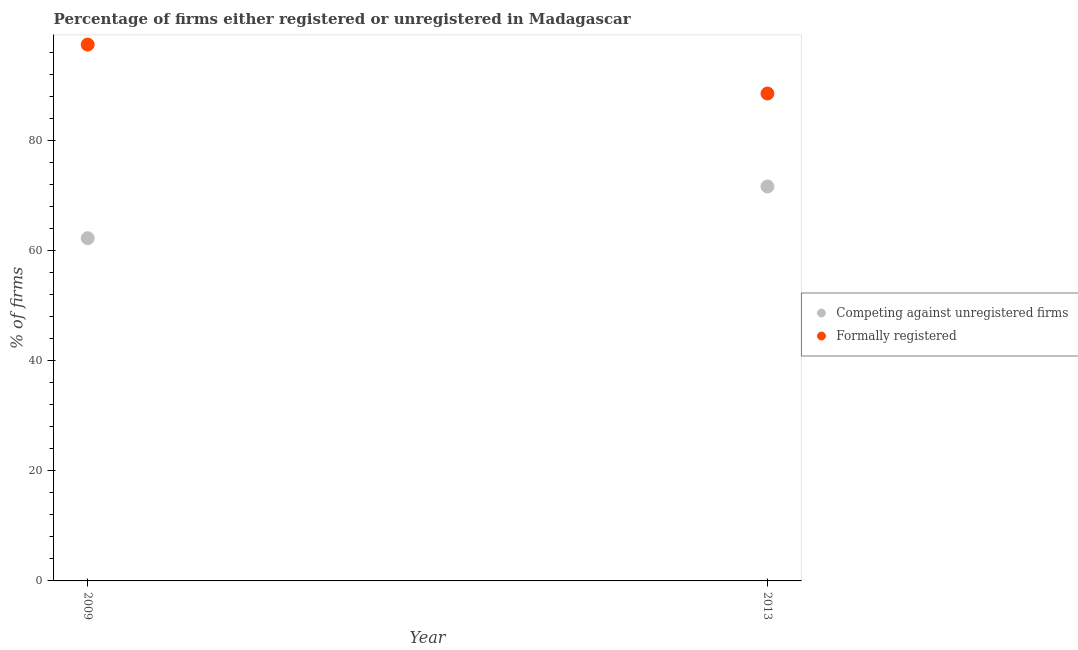What is the percentage of registered firms in 2009?
Give a very brief answer. 62.3. Across all years, what is the maximum percentage of formally registered firms?
Give a very brief answer. 97.5. Across all years, what is the minimum percentage of formally registered firms?
Keep it short and to the point. 88.6. In which year was the percentage of formally registered firms maximum?
Provide a short and direct response. 2009. In which year was the percentage of registered firms minimum?
Make the answer very short. 2009. What is the total percentage of formally registered firms in the graph?
Make the answer very short. 186.1. What is the difference between the percentage of registered firms in 2009 and that in 2013?
Give a very brief answer. -9.4. What is the difference between the percentage of registered firms in 2013 and the percentage of formally registered firms in 2009?
Provide a succinct answer. -25.8. What is the average percentage of formally registered firms per year?
Offer a terse response. 93.05. In the year 2009, what is the difference between the percentage of registered firms and percentage of formally registered firms?
Make the answer very short. -35.2. In how many years, is the percentage of formally registered firms greater than 84 %?
Keep it short and to the point. 2. What is the ratio of the percentage of formally registered firms in 2009 to that in 2013?
Ensure brevity in your answer.  1.1. In how many years, is the percentage of registered firms greater than the average percentage of registered firms taken over all years?
Offer a terse response. 1. Is the percentage of formally registered firms strictly greater than the percentage of registered firms over the years?
Ensure brevity in your answer.  Yes. How many dotlines are there?
Give a very brief answer. 2. How many years are there in the graph?
Your answer should be compact. 2. Are the values on the major ticks of Y-axis written in scientific E-notation?
Give a very brief answer. No. Does the graph contain any zero values?
Provide a succinct answer. No. Does the graph contain grids?
Provide a short and direct response. No. Where does the legend appear in the graph?
Ensure brevity in your answer.  Center right. What is the title of the graph?
Your response must be concise. Percentage of firms either registered or unregistered in Madagascar. What is the label or title of the Y-axis?
Your answer should be very brief. % of firms. What is the % of firms of Competing against unregistered firms in 2009?
Your answer should be compact. 62.3. What is the % of firms in Formally registered in 2009?
Provide a short and direct response. 97.5. What is the % of firms in Competing against unregistered firms in 2013?
Your answer should be compact. 71.7. What is the % of firms of Formally registered in 2013?
Keep it short and to the point. 88.6. Across all years, what is the maximum % of firms of Competing against unregistered firms?
Provide a short and direct response. 71.7. Across all years, what is the maximum % of firms of Formally registered?
Provide a succinct answer. 97.5. Across all years, what is the minimum % of firms of Competing against unregistered firms?
Keep it short and to the point. 62.3. Across all years, what is the minimum % of firms of Formally registered?
Your answer should be very brief. 88.6. What is the total % of firms in Competing against unregistered firms in the graph?
Your answer should be compact. 134. What is the total % of firms in Formally registered in the graph?
Give a very brief answer. 186.1. What is the difference between the % of firms of Formally registered in 2009 and that in 2013?
Offer a terse response. 8.9. What is the difference between the % of firms in Competing against unregistered firms in 2009 and the % of firms in Formally registered in 2013?
Your response must be concise. -26.3. What is the average % of firms in Formally registered per year?
Your answer should be compact. 93.05. In the year 2009, what is the difference between the % of firms in Competing against unregistered firms and % of firms in Formally registered?
Ensure brevity in your answer.  -35.2. In the year 2013, what is the difference between the % of firms in Competing against unregistered firms and % of firms in Formally registered?
Give a very brief answer. -16.9. What is the ratio of the % of firms in Competing against unregistered firms in 2009 to that in 2013?
Ensure brevity in your answer.  0.87. What is the ratio of the % of firms in Formally registered in 2009 to that in 2013?
Your response must be concise. 1.1. What is the difference between the highest and the second highest % of firms in Competing against unregistered firms?
Give a very brief answer. 9.4. What is the difference between the highest and the second highest % of firms of Formally registered?
Offer a terse response. 8.9. What is the difference between the highest and the lowest % of firms of Formally registered?
Offer a very short reply. 8.9. 